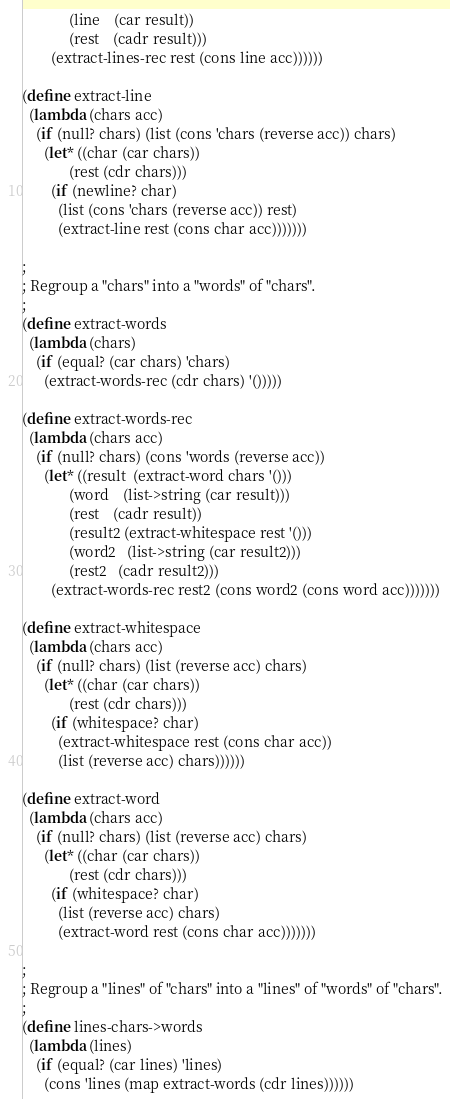Convert code to text. <code><loc_0><loc_0><loc_500><loc_500><_Scheme_>             (line    (car result))
             (rest    (cadr result)))
        (extract-lines-rec rest (cons line acc))))))

(define extract-line
  (lambda (chars acc)
    (if (null? chars) (list (cons 'chars (reverse acc)) chars)
      (let* ((char (car chars))
             (rest (cdr chars)))
        (if (newline? char)
          (list (cons 'chars (reverse acc)) rest)
          (extract-line rest (cons char acc)))))))

;
; Regroup a "chars" into a "words" of "chars".
;
(define extract-words
  (lambda (chars)
    (if (equal? (car chars) 'chars)
      (extract-words-rec (cdr chars) '()))))

(define extract-words-rec
  (lambda (chars acc)
    (if (null? chars) (cons 'words (reverse acc))
      (let* ((result  (extract-word chars '()))
             (word    (list->string (car result)))
             (rest    (cadr result))
             (result2 (extract-whitespace rest '()))
             (word2   (list->string (car result2)))
             (rest2   (cadr result2)))
        (extract-words-rec rest2 (cons word2 (cons word acc)))))))

(define extract-whitespace
  (lambda (chars acc)
    (if (null? chars) (list (reverse acc) chars)
      (let* ((char (car chars))
             (rest (cdr chars)))
        (if (whitespace? char)
          (extract-whitespace rest (cons char acc))
          (list (reverse acc) chars))))))

(define extract-word
  (lambda (chars acc)
    (if (null? chars) (list (reverse acc) chars)
      (let* ((char (car chars))
             (rest (cdr chars)))
        (if (whitespace? char)
          (list (reverse acc) chars)
          (extract-word rest (cons char acc)))))))

;
; Regroup a "lines" of "chars" into a "lines" of "words" of "chars".
;
(define lines-chars->words
  (lambda (lines)
    (if (equal? (car lines) 'lines)
      (cons 'lines (map extract-words (cdr lines))))))
</code> 